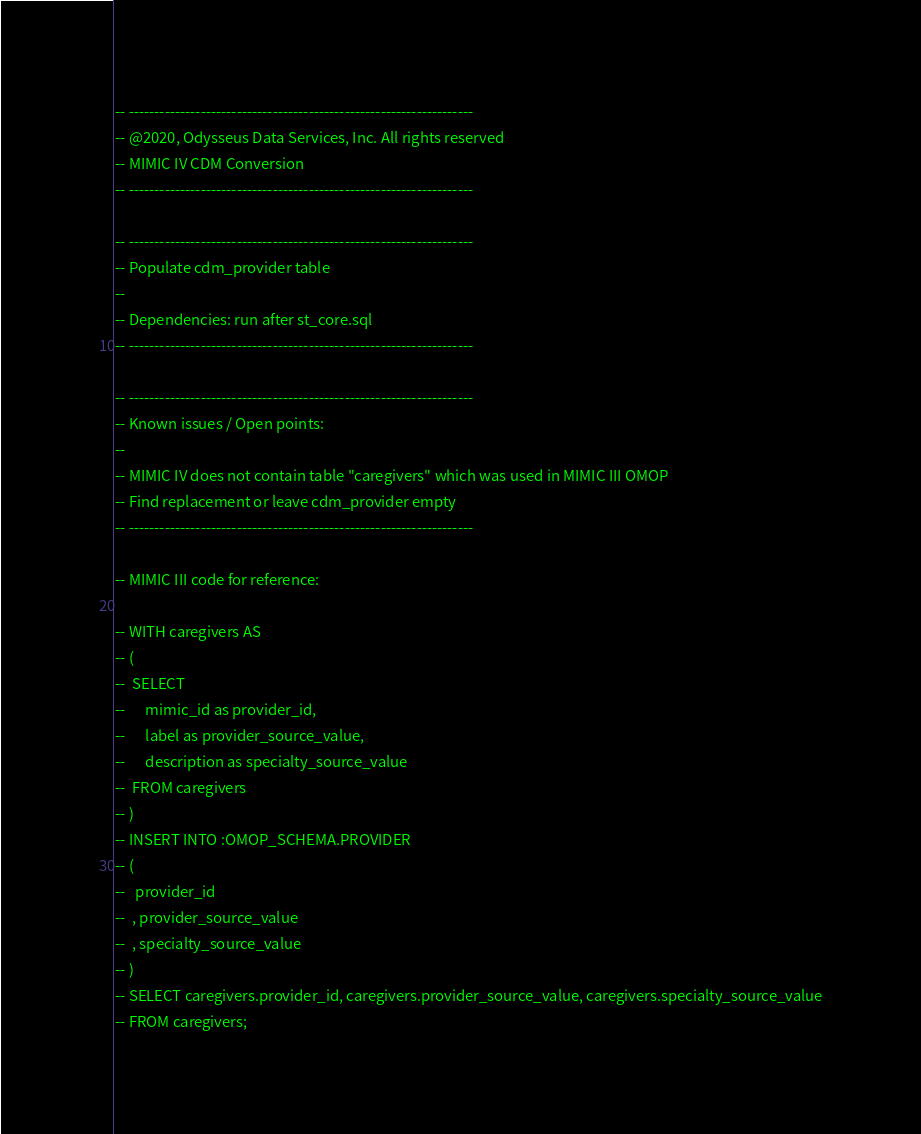Convert code to text. <code><loc_0><loc_0><loc_500><loc_500><_SQL_>-- -------------------------------------------------------------------
-- @2020, Odysseus Data Services, Inc. All rights reserved
-- MIMIC IV CDM Conversion
-- -------------------------------------------------------------------

-- -------------------------------------------------------------------
-- Populate cdm_provider table
-- 
-- Dependencies: run after st_core.sql
-- -------------------------------------------------------------------

-- -------------------------------------------------------------------
-- Known issues / Open points:
--
-- MIMIC IV does not contain table "caregivers" which was used in MIMIC III OMOP
-- Find replacement or leave cdm_provider empty
-- -------------------------------------------------------------------

-- MIMIC III code for reference:

-- WITH caregivers AS 
-- (
--  SELECT 
--      mimic_id as provider_id, 
--      label as provider_source_value, 
--      description as specialty_source_value 
--  FROM caregivers
-- )
-- INSERT INTO :OMOP_SCHEMA.PROVIDER
-- (
--   provider_id
--  , provider_source_value
--  , specialty_source_value
-- )
-- SELECT caregivers.provider_id, caregivers.provider_source_value, caregivers.specialty_source_value
-- FROM caregivers;
</code> 